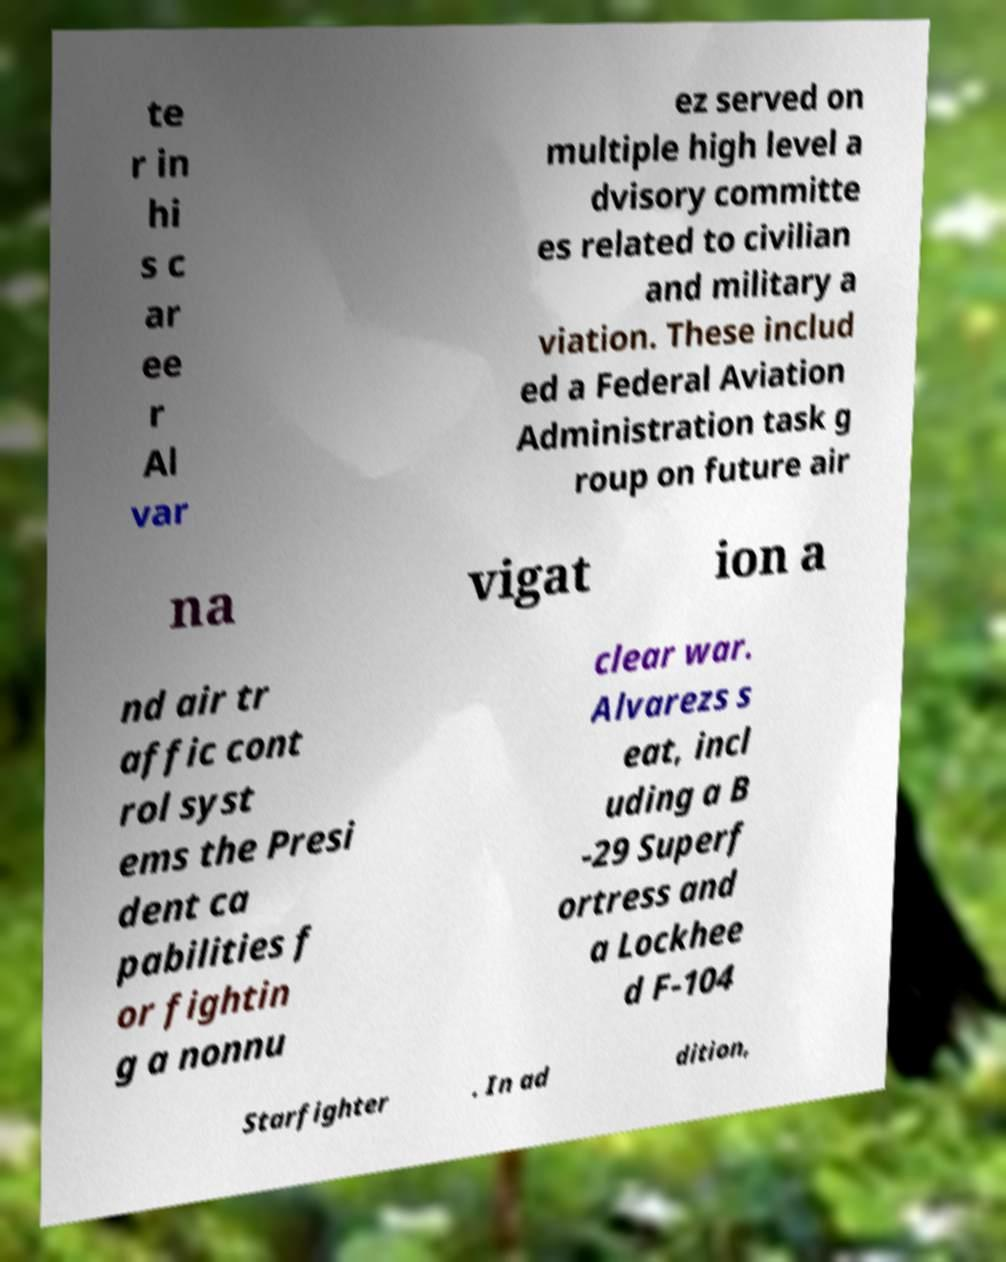There's text embedded in this image that I need extracted. Can you transcribe it verbatim? te r in hi s c ar ee r Al var ez served on multiple high level a dvisory committe es related to civilian and military a viation. These includ ed a Federal Aviation Administration task g roup on future air na vigat ion a nd air tr affic cont rol syst ems the Presi dent ca pabilities f or fightin g a nonnu clear war. Alvarezs s eat, incl uding a B -29 Superf ortress and a Lockhee d F-104 Starfighter . In ad dition, 